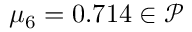<formula> <loc_0><loc_0><loc_500><loc_500>\mu _ { 6 } = 0 . 7 1 4 \in \mathcal { P }</formula> 